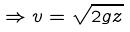Convert formula to latex. <formula><loc_0><loc_0><loc_500><loc_500>\Rightarrow v = \sqrt { 2 g z }</formula> 